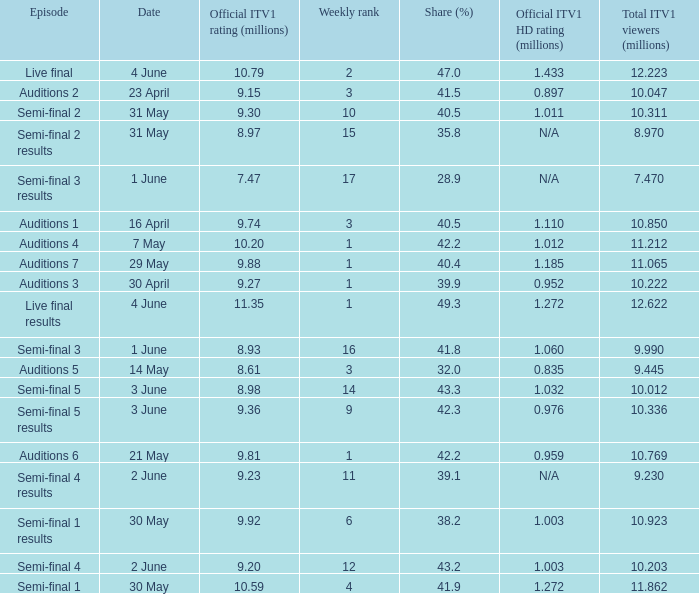When was the episode that had a share (%) of 41.5? 23 April. 